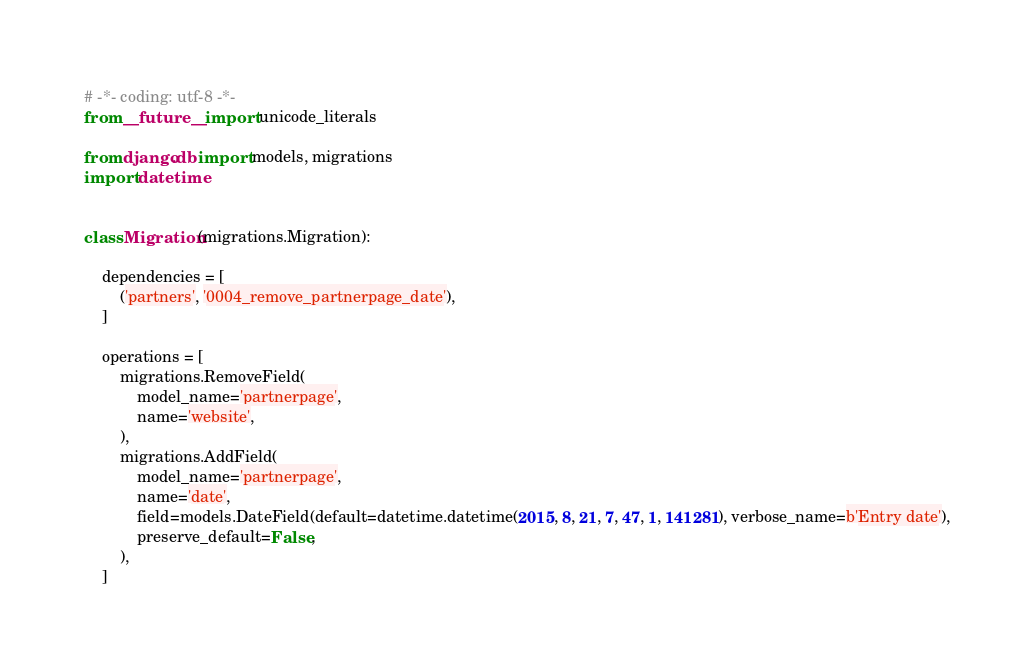Convert code to text. <code><loc_0><loc_0><loc_500><loc_500><_Python_># -*- coding: utf-8 -*-
from __future__ import unicode_literals

from django.db import models, migrations
import datetime


class Migration(migrations.Migration):

    dependencies = [
        ('partners', '0004_remove_partnerpage_date'),
    ]

    operations = [
        migrations.RemoveField(
            model_name='partnerpage',
            name='website',
        ),
        migrations.AddField(
            model_name='partnerpage',
            name='date',
            field=models.DateField(default=datetime.datetime(2015, 8, 21, 7, 47, 1, 141281), verbose_name=b'Entry date'),
            preserve_default=False,
        ),
    ]
</code> 